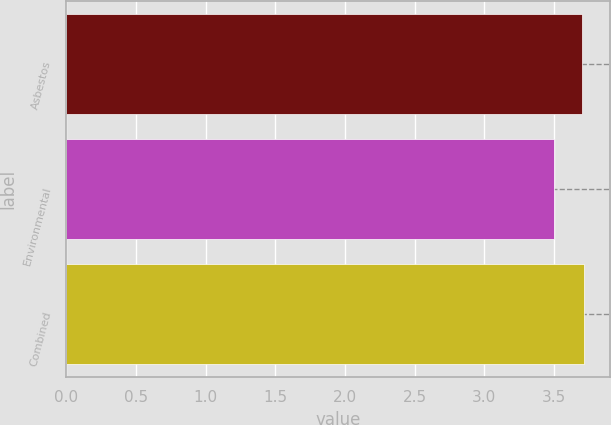<chart> <loc_0><loc_0><loc_500><loc_500><bar_chart><fcel>Asbestos<fcel>Environmental<fcel>Combined<nl><fcel>3.7<fcel>3.5<fcel>3.72<nl></chart> 